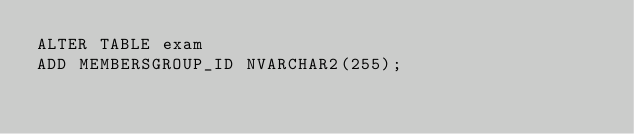<code> <loc_0><loc_0><loc_500><loc_500><_SQL_>ALTER TABLE exam
ADD MEMBERSGROUP_ID NVARCHAR2(255);</code> 